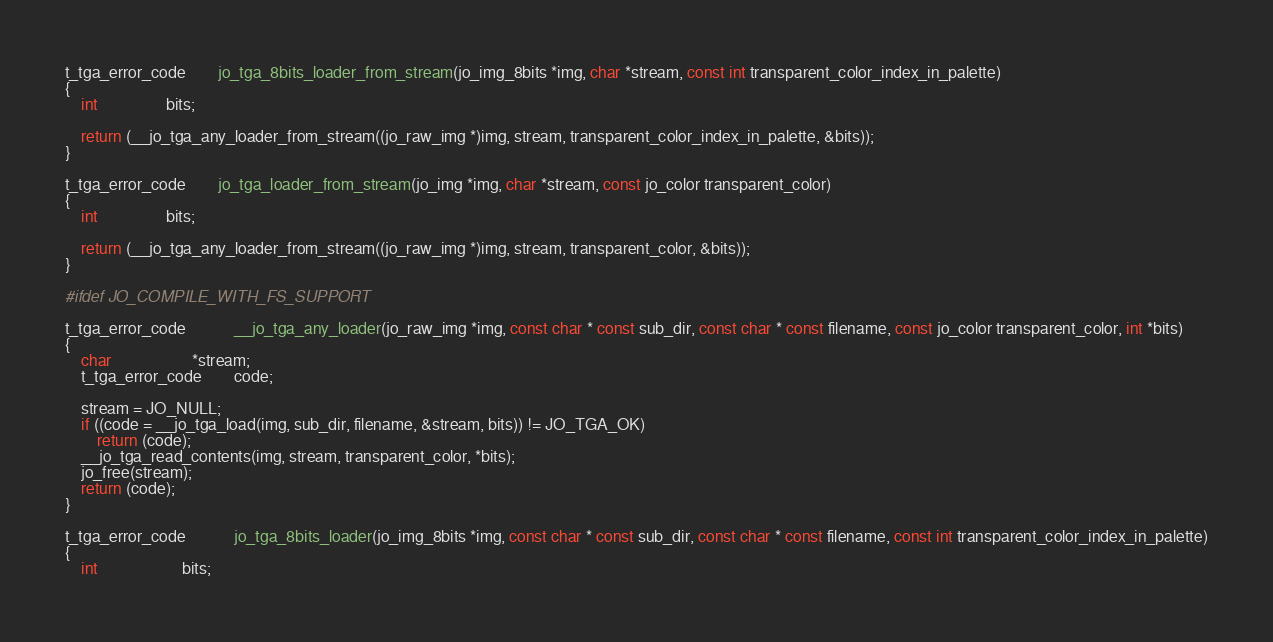<code> <loc_0><loc_0><loc_500><loc_500><_C_>t_tga_error_code		jo_tga_8bits_loader_from_stream(jo_img_8bits *img, char *stream, const int transparent_color_index_in_palette)
{
    int                 bits;

    return (__jo_tga_any_loader_from_stream((jo_raw_img *)img, stream, transparent_color_index_in_palette, &bits));
}

t_tga_error_code		jo_tga_loader_from_stream(jo_img *img, char *stream, const jo_color transparent_color)
{
    int                 bits;

    return (__jo_tga_any_loader_from_stream((jo_raw_img *)img, stream, transparent_color, &bits));
}

#ifdef JO_COMPILE_WITH_FS_SUPPORT

t_tga_error_code		    __jo_tga_any_loader(jo_raw_img *img, const char * const sub_dir, const char * const filename, const jo_color transparent_color, int *bits)
{
    char                    *stream;
    t_tga_error_code	    code;

    stream = JO_NULL;
    if ((code = __jo_tga_load(img, sub_dir, filename, &stream, bits)) != JO_TGA_OK)
        return (code);
    __jo_tga_read_contents(img, stream, transparent_color, *bits);
    jo_free(stream);
    return (code);
}

t_tga_error_code		    jo_tga_8bits_loader(jo_img_8bits *img, const char * const sub_dir, const char * const filename, const int transparent_color_index_in_palette)
{
    int                     bits;
</code> 